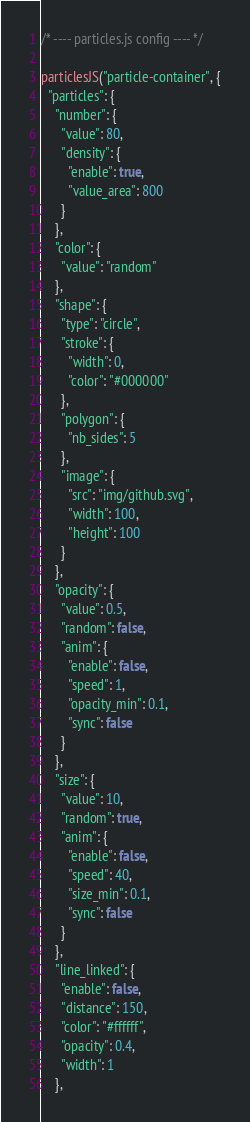Convert code to text. <code><loc_0><loc_0><loc_500><loc_500><_JavaScript_>/* ---- particles.js config ---- */

particlesJS("particle-container", {
  "particles": {
    "number": {
      "value": 80,
      "density": {
        "enable": true,
        "value_area": 800
      }
    },
    "color": {
      "value": "random"
    },
    "shape": {
      "type": "circle",
      "stroke": {
        "width": 0,
        "color": "#000000"
      },
      "polygon": {
        "nb_sides": 5
      },
      "image": {
        "src": "img/github.svg",
        "width": 100,
        "height": 100
      }
    },
    "opacity": {
      "value": 0.5,
      "random": false,
      "anim": {
        "enable": false,
        "speed": 1,
        "opacity_min": 0.1,
        "sync": false
      }
    },
    "size": {
      "value": 10,
      "random": true,
      "anim": {
        "enable": false,
        "speed": 40,
        "size_min": 0.1,
        "sync": false
      }
    },
    "line_linked": {
      "enable": false,
      "distance": 150,
      "color": "#ffffff",
      "opacity": 0.4,
      "width": 1
    },</code> 